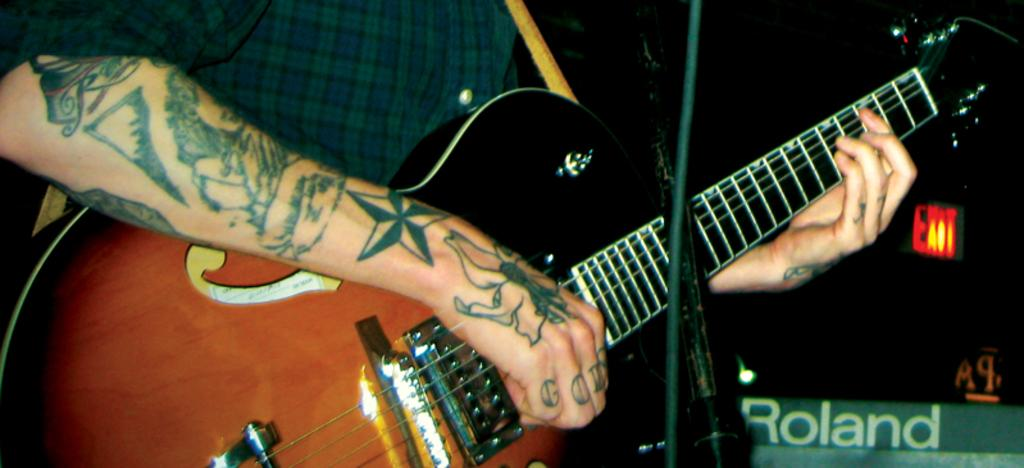What is the man in the image doing? The man is playing a guitar in the image. Can you describe any distinguishing features of the man? The man has a tattoo on his hand. What other object is present in the image related to the man's activity? There is a microphone stand in the image. How many snakes can be seen slithering around the man's feet in the image? There are no snakes present in the image. What type of fang can be seen on the man's guitar in the image? There are no fangs present on the man's guitar in the image. 